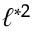Convert formula to latex. <formula><loc_0><loc_0><loc_500><loc_500>\ell ^ { * 2 }</formula> 